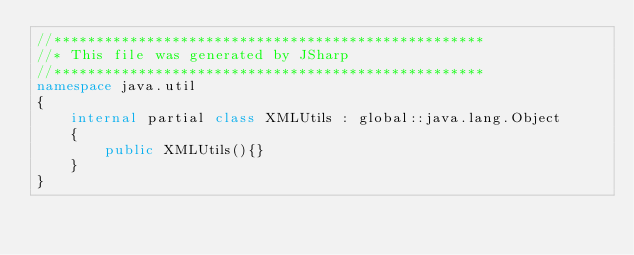<code> <loc_0><loc_0><loc_500><loc_500><_C#_>//***************************************************
//* This file was generated by JSharp
//***************************************************
namespace java.util
{
    internal partial class XMLUtils : global::java.lang.Object
    {
        public XMLUtils(){}
    }
}
</code> 